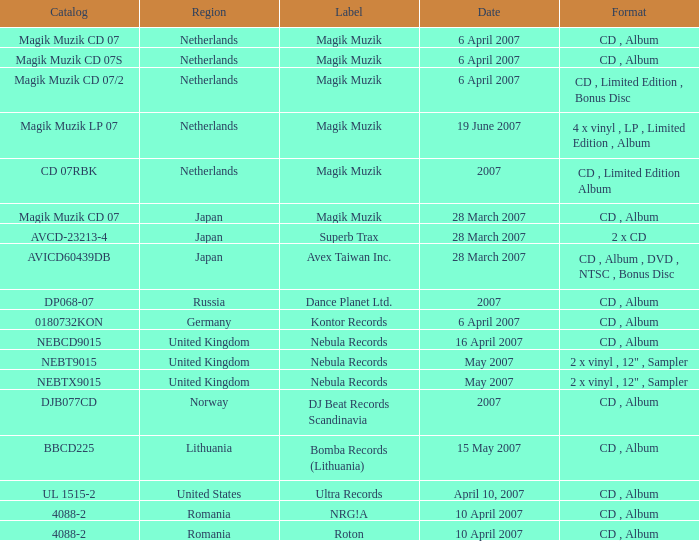For the catalog title DP068-07, what formats are available? CD , Album. 